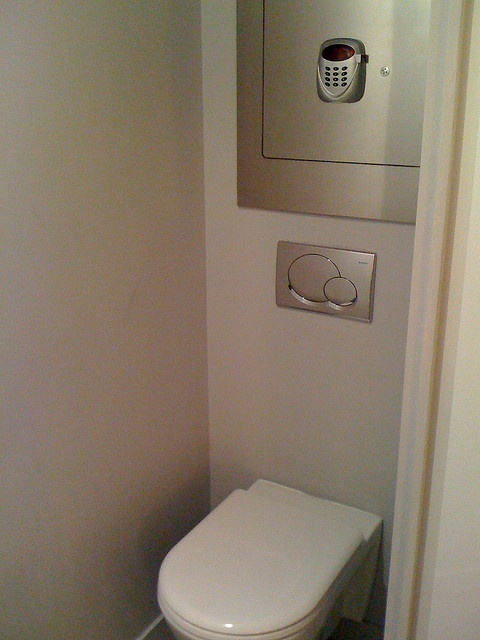Describe the objects in this image and their specific colors. I can see a toilet in gray, darkgray, and black tones in this image. 